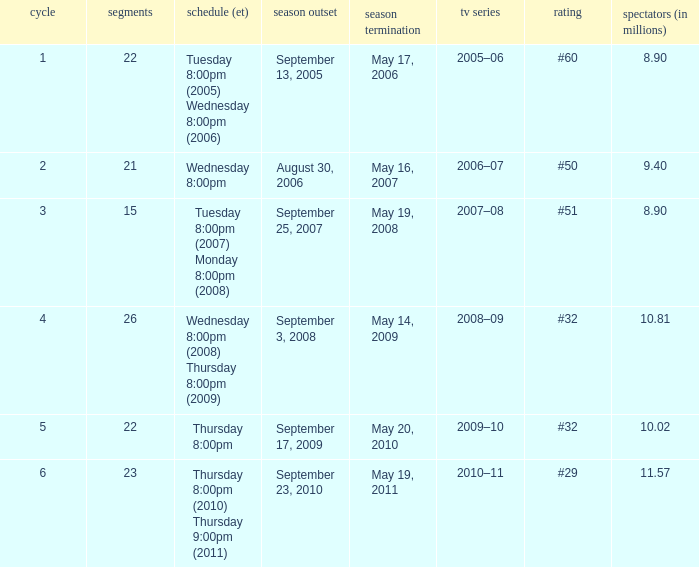When did the season finale achieve a viewership of 10.02 million people? May 20, 2010. 